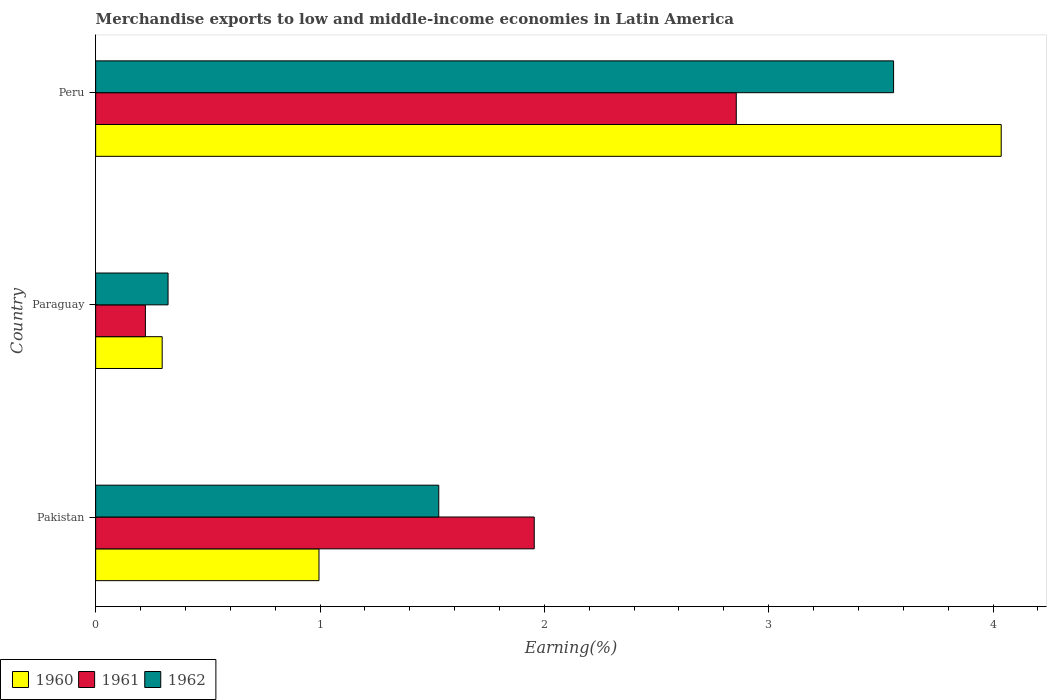Are the number of bars on each tick of the Y-axis equal?
Offer a terse response. Yes. How many bars are there on the 3rd tick from the bottom?
Provide a succinct answer. 3. What is the label of the 3rd group of bars from the top?
Provide a succinct answer. Pakistan. What is the percentage of amount earned from merchandise exports in 1962 in Peru?
Your response must be concise. 3.56. Across all countries, what is the maximum percentage of amount earned from merchandise exports in 1962?
Make the answer very short. 3.56. Across all countries, what is the minimum percentage of amount earned from merchandise exports in 1961?
Your answer should be very brief. 0.22. In which country was the percentage of amount earned from merchandise exports in 1961 maximum?
Provide a succinct answer. Peru. In which country was the percentage of amount earned from merchandise exports in 1961 minimum?
Ensure brevity in your answer.  Paraguay. What is the total percentage of amount earned from merchandise exports in 1962 in the graph?
Give a very brief answer. 5.41. What is the difference between the percentage of amount earned from merchandise exports in 1960 in Pakistan and that in Paraguay?
Provide a short and direct response. 0.7. What is the difference between the percentage of amount earned from merchandise exports in 1961 in Pakistan and the percentage of amount earned from merchandise exports in 1962 in Paraguay?
Your answer should be very brief. 1.63. What is the average percentage of amount earned from merchandise exports in 1962 per country?
Your answer should be compact. 1.8. What is the difference between the percentage of amount earned from merchandise exports in 1961 and percentage of amount earned from merchandise exports in 1960 in Peru?
Give a very brief answer. -1.18. In how many countries, is the percentage of amount earned from merchandise exports in 1961 greater than 0.4 %?
Your response must be concise. 2. What is the ratio of the percentage of amount earned from merchandise exports in 1962 in Pakistan to that in Peru?
Give a very brief answer. 0.43. Is the difference between the percentage of amount earned from merchandise exports in 1961 in Pakistan and Peru greater than the difference between the percentage of amount earned from merchandise exports in 1960 in Pakistan and Peru?
Offer a terse response. Yes. What is the difference between the highest and the second highest percentage of amount earned from merchandise exports in 1961?
Provide a succinct answer. 0.9. What is the difference between the highest and the lowest percentage of amount earned from merchandise exports in 1960?
Keep it short and to the point. 3.74. How many bars are there?
Offer a terse response. 9. How many countries are there in the graph?
Ensure brevity in your answer.  3. Are the values on the major ticks of X-axis written in scientific E-notation?
Keep it short and to the point. No. How are the legend labels stacked?
Offer a very short reply. Horizontal. What is the title of the graph?
Your response must be concise. Merchandise exports to low and middle-income economies in Latin America. Does "1973" appear as one of the legend labels in the graph?
Give a very brief answer. No. What is the label or title of the X-axis?
Offer a terse response. Earning(%). What is the label or title of the Y-axis?
Keep it short and to the point. Country. What is the Earning(%) in 1960 in Pakistan?
Provide a short and direct response. 1. What is the Earning(%) in 1961 in Pakistan?
Ensure brevity in your answer.  1.95. What is the Earning(%) of 1962 in Pakistan?
Provide a short and direct response. 1.53. What is the Earning(%) in 1960 in Paraguay?
Your response must be concise. 0.3. What is the Earning(%) of 1961 in Paraguay?
Keep it short and to the point. 0.22. What is the Earning(%) in 1962 in Paraguay?
Offer a terse response. 0.32. What is the Earning(%) in 1960 in Peru?
Provide a short and direct response. 4.04. What is the Earning(%) of 1961 in Peru?
Ensure brevity in your answer.  2.86. What is the Earning(%) in 1962 in Peru?
Provide a short and direct response. 3.56. Across all countries, what is the maximum Earning(%) in 1960?
Your answer should be very brief. 4.04. Across all countries, what is the maximum Earning(%) in 1961?
Provide a succinct answer. 2.86. Across all countries, what is the maximum Earning(%) of 1962?
Make the answer very short. 3.56. Across all countries, what is the minimum Earning(%) in 1960?
Give a very brief answer. 0.3. Across all countries, what is the minimum Earning(%) of 1961?
Give a very brief answer. 0.22. Across all countries, what is the minimum Earning(%) in 1962?
Give a very brief answer. 0.32. What is the total Earning(%) in 1960 in the graph?
Your answer should be very brief. 5.33. What is the total Earning(%) in 1961 in the graph?
Give a very brief answer. 5.03. What is the total Earning(%) of 1962 in the graph?
Offer a very short reply. 5.41. What is the difference between the Earning(%) of 1960 in Pakistan and that in Paraguay?
Make the answer very short. 0.7. What is the difference between the Earning(%) in 1961 in Pakistan and that in Paraguay?
Provide a short and direct response. 1.73. What is the difference between the Earning(%) in 1962 in Pakistan and that in Paraguay?
Ensure brevity in your answer.  1.21. What is the difference between the Earning(%) of 1960 in Pakistan and that in Peru?
Provide a succinct answer. -3.04. What is the difference between the Earning(%) of 1961 in Pakistan and that in Peru?
Ensure brevity in your answer.  -0.9. What is the difference between the Earning(%) of 1962 in Pakistan and that in Peru?
Your answer should be compact. -2.03. What is the difference between the Earning(%) of 1960 in Paraguay and that in Peru?
Provide a short and direct response. -3.74. What is the difference between the Earning(%) in 1961 in Paraguay and that in Peru?
Provide a short and direct response. -2.63. What is the difference between the Earning(%) of 1962 in Paraguay and that in Peru?
Keep it short and to the point. -3.23. What is the difference between the Earning(%) in 1960 in Pakistan and the Earning(%) in 1961 in Paraguay?
Provide a succinct answer. 0.77. What is the difference between the Earning(%) of 1960 in Pakistan and the Earning(%) of 1962 in Paraguay?
Your answer should be compact. 0.67. What is the difference between the Earning(%) of 1961 in Pakistan and the Earning(%) of 1962 in Paraguay?
Provide a succinct answer. 1.63. What is the difference between the Earning(%) in 1960 in Pakistan and the Earning(%) in 1961 in Peru?
Your response must be concise. -1.86. What is the difference between the Earning(%) of 1960 in Pakistan and the Earning(%) of 1962 in Peru?
Offer a very short reply. -2.56. What is the difference between the Earning(%) of 1961 in Pakistan and the Earning(%) of 1962 in Peru?
Provide a succinct answer. -1.6. What is the difference between the Earning(%) in 1960 in Paraguay and the Earning(%) in 1961 in Peru?
Provide a succinct answer. -2.56. What is the difference between the Earning(%) of 1960 in Paraguay and the Earning(%) of 1962 in Peru?
Offer a terse response. -3.26. What is the difference between the Earning(%) of 1961 in Paraguay and the Earning(%) of 1962 in Peru?
Offer a very short reply. -3.33. What is the average Earning(%) of 1960 per country?
Your answer should be very brief. 1.78. What is the average Earning(%) of 1961 per country?
Provide a succinct answer. 1.68. What is the average Earning(%) of 1962 per country?
Offer a very short reply. 1.8. What is the difference between the Earning(%) of 1960 and Earning(%) of 1961 in Pakistan?
Make the answer very short. -0.96. What is the difference between the Earning(%) in 1960 and Earning(%) in 1962 in Pakistan?
Offer a very short reply. -0.53. What is the difference between the Earning(%) in 1961 and Earning(%) in 1962 in Pakistan?
Provide a short and direct response. 0.43. What is the difference between the Earning(%) of 1960 and Earning(%) of 1961 in Paraguay?
Your answer should be very brief. 0.07. What is the difference between the Earning(%) of 1960 and Earning(%) of 1962 in Paraguay?
Offer a terse response. -0.03. What is the difference between the Earning(%) of 1961 and Earning(%) of 1962 in Paraguay?
Give a very brief answer. -0.1. What is the difference between the Earning(%) in 1960 and Earning(%) in 1961 in Peru?
Your answer should be compact. 1.18. What is the difference between the Earning(%) in 1960 and Earning(%) in 1962 in Peru?
Offer a terse response. 0.48. What is the difference between the Earning(%) of 1961 and Earning(%) of 1962 in Peru?
Provide a succinct answer. -0.7. What is the ratio of the Earning(%) of 1960 in Pakistan to that in Paraguay?
Offer a very short reply. 3.36. What is the ratio of the Earning(%) of 1961 in Pakistan to that in Paraguay?
Keep it short and to the point. 8.82. What is the ratio of the Earning(%) in 1962 in Pakistan to that in Paraguay?
Your response must be concise. 4.74. What is the ratio of the Earning(%) in 1960 in Pakistan to that in Peru?
Offer a very short reply. 0.25. What is the ratio of the Earning(%) of 1961 in Pakistan to that in Peru?
Keep it short and to the point. 0.68. What is the ratio of the Earning(%) of 1962 in Pakistan to that in Peru?
Make the answer very short. 0.43. What is the ratio of the Earning(%) in 1960 in Paraguay to that in Peru?
Ensure brevity in your answer.  0.07. What is the ratio of the Earning(%) of 1961 in Paraguay to that in Peru?
Provide a succinct answer. 0.08. What is the ratio of the Earning(%) of 1962 in Paraguay to that in Peru?
Offer a very short reply. 0.09. What is the difference between the highest and the second highest Earning(%) in 1960?
Provide a succinct answer. 3.04. What is the difference between the highest and the second highest Earning(%) of 1961?
Make the answer very short. 0.9. What is the difference between the highest and the second highest Earning(%) in 1962?
Give a very brief answer. 2.03. What is the difference between the highest and the lowest Earning(%) in 1960?
Your response must be concise. 3.74. What is the difference between the highest and the lowest Earning(%) of 1961?
Ensure brevity in your answer.  2.63. What is the difference between the highest and the lowest Earning(%) in 1962?
Offer a terse response. 3.23. 